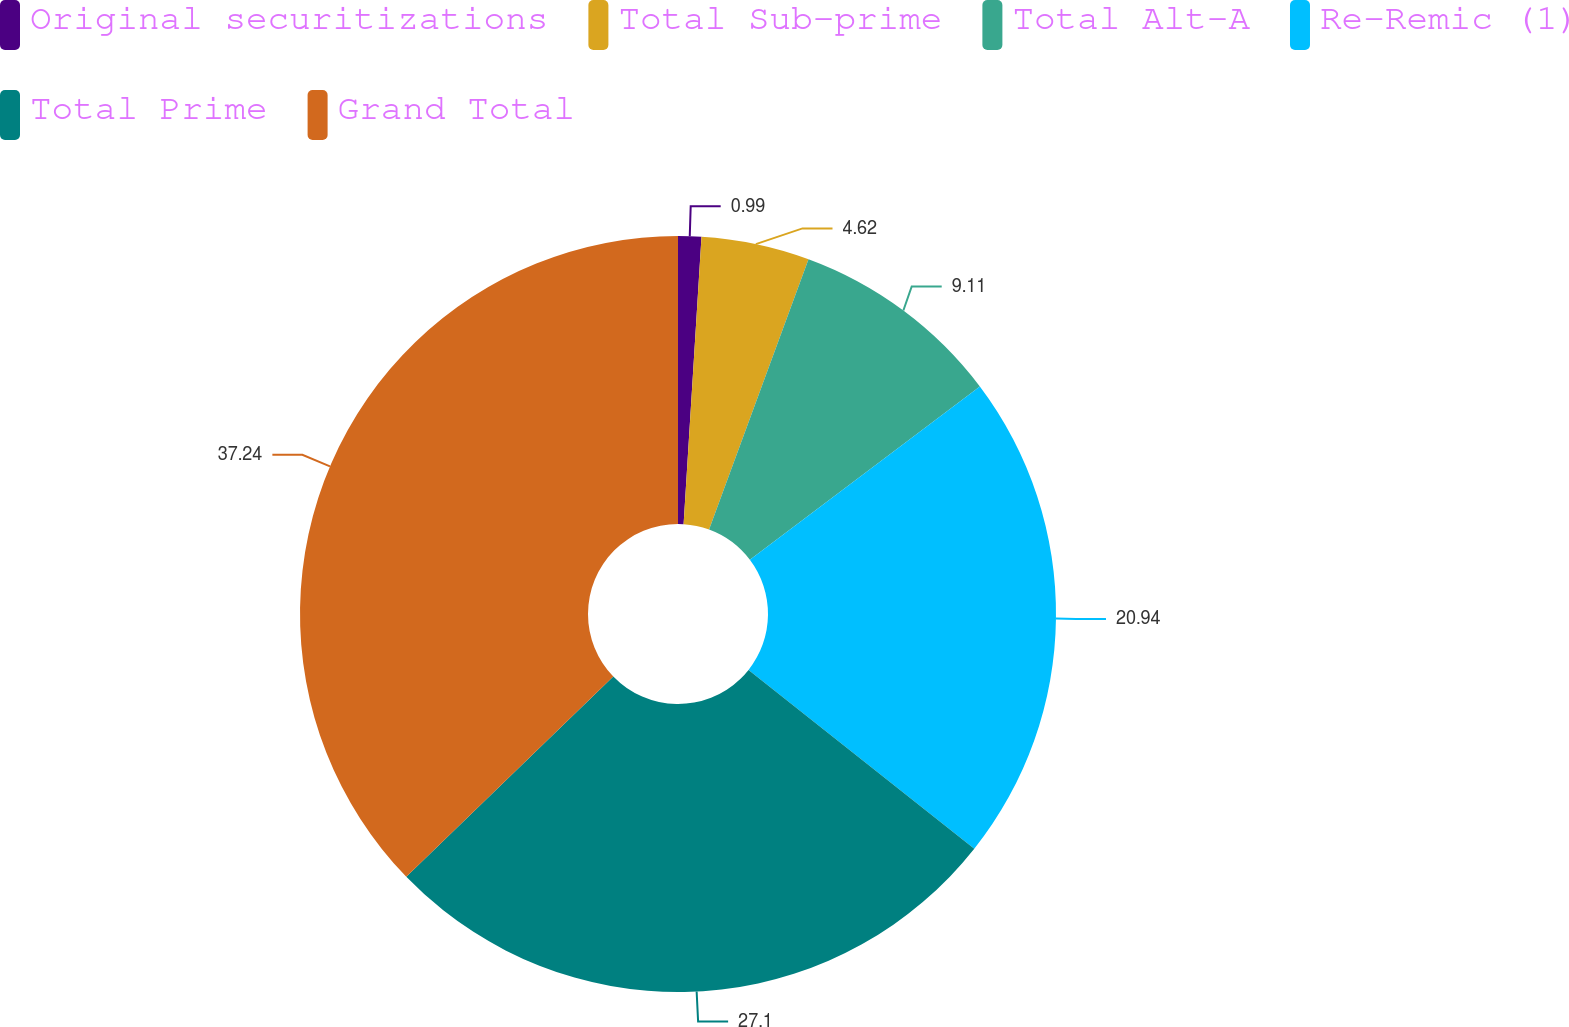Convert chart. <chart><loc_0><loc_0><loc_500><loc_500><pie_chart><fcel>Original securitizations<fcel>Total Sub-prime<fcel>Total Alt-A<fcel>Re-Remic (1)<fcel>Total Prime<fcel>Grand Total<nl><fcel>0.99%<fcel>4.62%<fcel>9.11%<fcel>20.94%<fcel>27.1%<fcel>37.23%<nl></chart> 